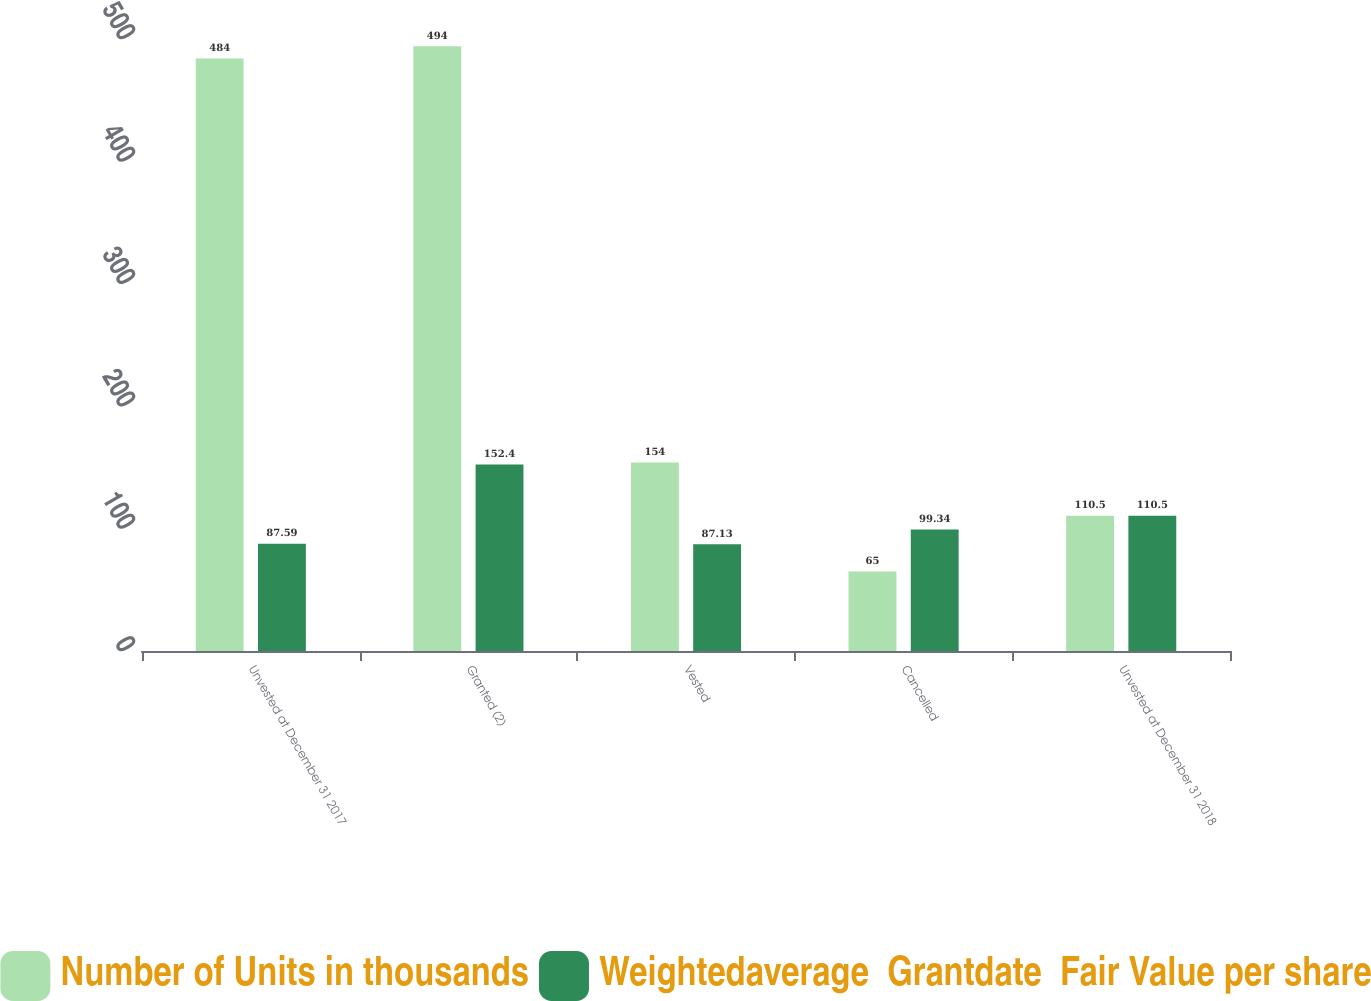Convert chart. <chart><loc_0><loc_0><loc_500><loc_500><stacked_bar_chart><ecel><fcel>Unvested at December 31 2017<fcel>Granted (2)<fcel>Vested<fcel>Cancelled<fcel>Unvested at December 31 2018<nl><fcel>Number of Units in thousands<fcel>484<fcel>494<fcel>154<fcel>65<fcel>110.5<nl><fcel>Weightedaverage  Grantdate  Fair Value per share<fcel>87.59<fcel>152.4<fcel>87.13<fcel>99.34<fcel>110.5<nl></chart> 